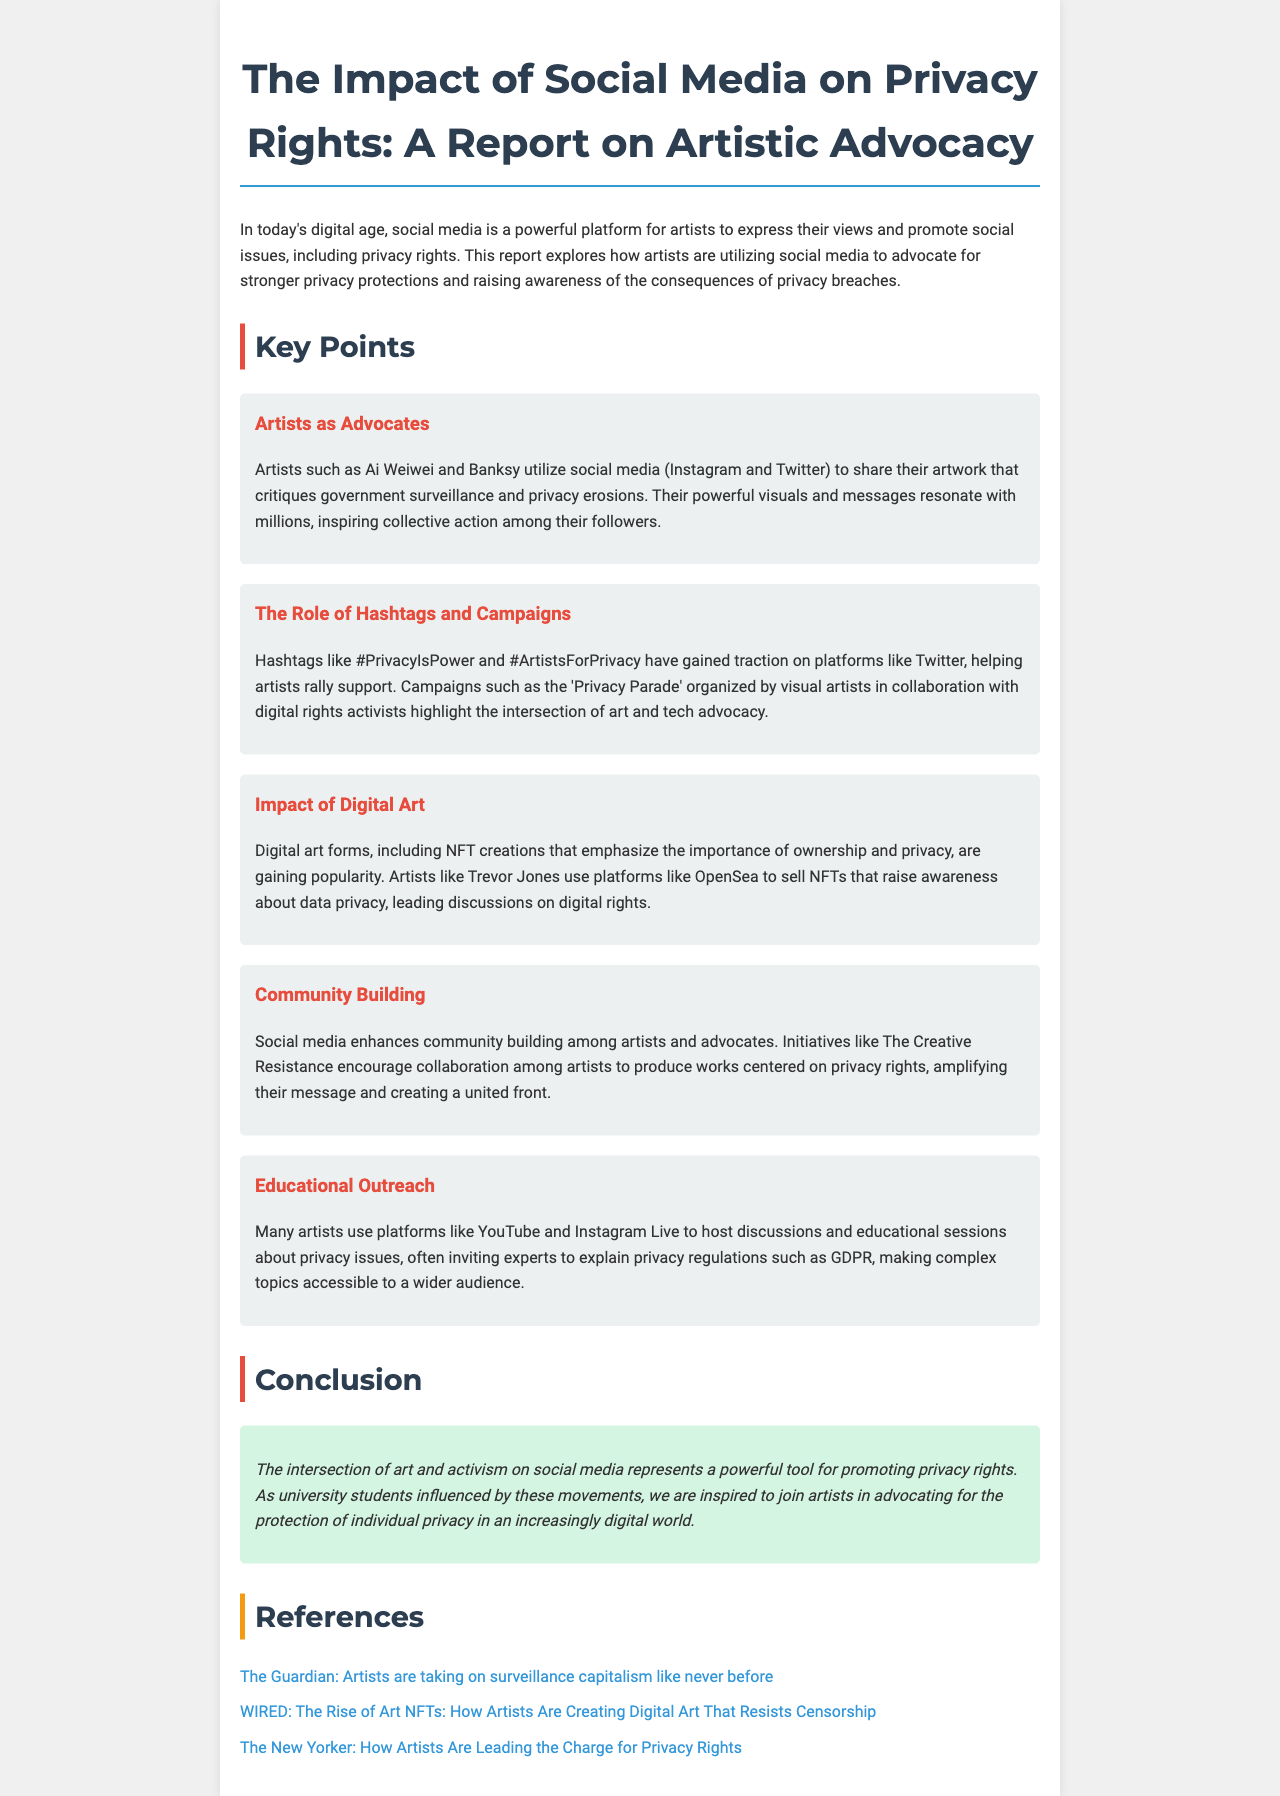What is the title of the report? The title appears in the header of the document and is presented prominently.
Answer: The Impact of Social Media on Privacy Rights: A Report on Artistic Advocacy Who are two artists mentioned in the report? These artists are highlighted in the section discussing their advocacy work on social media.
Answer: Ai Weiwei and Banksy What hashtag is associated with supporting privacy rights? This hashtag is highlighted in the section discussing campaigns that artists have initiated on social media.
Answer: #PrivacyIsPower What type of art form emphasizes ownership and privacy? This is mentioned in the section discussing the impact of digital art.
Answer: NFT Which platform do artists use to host educational discussions about privacy issues? The document specifically mentions a popular social media platform used for these sessions.
Answer: YouTube How do artists enhance community building according to the report? The report details initiatives that focus on collaboration among artists to produce works about privacy rights.
Answer: The Creative Resistance What is the main conclusion of the report? The conclusion summarizes the overall impression of the relationship between art and advocacy for privacy rights.
Answer: A powerful tool for promoting privacy rights What is one campaign mentioned that focuses on privacy advocacy? The report provides an example of a specific campaign related to privacy rights.
Answer: Privacy Parade 